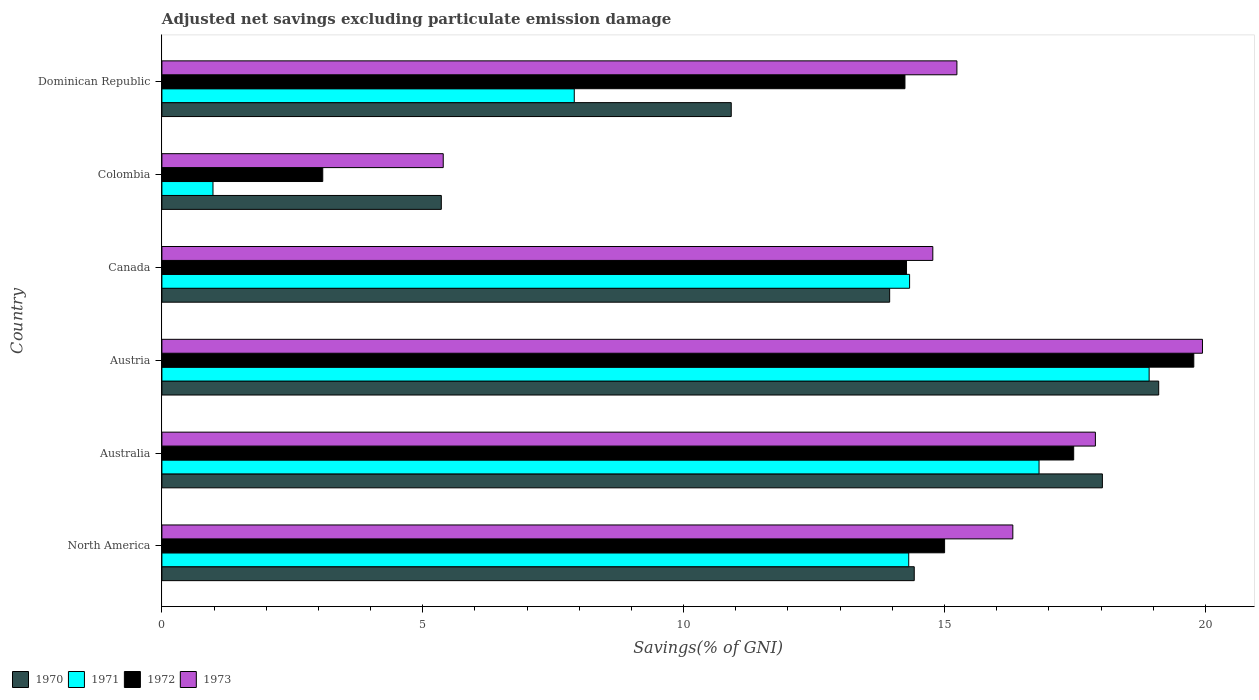Are the number of bars per tick equal to the number of legend labels?
Provide a short and direct response. Yes. How many bars are there on the 4th tick from the bottom?
Your answer should be very brief. 4. What is the adjusted net savings in 1972 in North America?
Provide a short and direct response. 15. Across all countries, what is the maximum adjusted net savings in 1973?
Provide a succinct answer. 19.94. Across all countries, what is the minimum adjusted net savings in 1972?
Make the answer very short. 3.08. In which country was the adjusted net savings in 1972 maximum?
Your answer should be very brief. Austria. In which country was the adjusted net savings in 1970 minimum?
Your response must be concise. Colombia. What is the total adjusted net savings in 1970 in the graph?
Your response must be concise. 81.77. What is the difference between the adjusted net savings in 1972 in Austria and that in Canada?
Provide a succinct answer. 5.51. What is the difference between the adjusted net savings in 1971 in Colombia and the adjusted net savings in 1970 in Canada?
Make the answer very short. -12.97. What is the average adjusted net savings in 1971 per country?
Keep it short and to the point. 12.21. What is the difference between the adjusted net savings in 1970 and adjusted net savings in 1971 in Dominican Republic?
Provide a succinct answer. 3.01. In how many countries, is the adjusted net savings in 1971 greater than 14 %?
Your response must be concise. 4. What is the ratio of the adjusted net savings in 1970 in Australia to that in Austria?
Provide a short and direct response. 0.94. Is the adjusted net savings in 1971 in Australia less than that in North America?
Ensure brevity in your answer.  No. What is the difference between the highest and the second highest adjusted net savings in 1973?
Make the answer very short. 2.05. What is the difference between the highest and the lowest adjusted net savings in 1971?
Your response must be concise. 17.94. What does the 3rd bar from the bottom in Canada represents?
Make the answer very short. 1972. How many countries are there in the graph?
Ensure brevity in your answer.  6. Does the graph contain grids?
Your answer should be very brief. No. What is the title of the graph?
Your answer should be compact. Adjusted net savings excluding particulate emission damage. What is the label or title of the X-axis?
Ensure brevity in your answer.  Savings(% of GNI). What is the label or title of the Y-axis?
Your answer should be very brief. Country. What is the Savings(% of GNI) in 1970 in North America?
Make the answer very short. 14.42. What is the Savings(% of GNI) in 1971 in North America?
Provide a succinct answer. 14.31. What is the Savings(% of GNI) in 1972 in North America?
Offer a very short reply. 15. What is the Savings(% of GNI) in 1973 in North America?
Provide a succinct answer. 16.31. What is the Savings(% of GNI) of 1970 in Australia?
Keep it short and to the point. 18.03. What is the Savings(% of GNI) in 1971 in Australia?
Your response must be concise. 16.81. What is the Savings(% of GNI) in 1972 in Australia?
Your response must be concise. 17.48. What is the Savings(% of GNI) of 1973 in Australia?
Your answer should be compact. 17.89. What is the Savings(% of GNI) of 1970 in Austria?
Offer a very short reply. 19.11. What is the Savings(% of GNI) in 1971 in Austria?
Offer a very short reply. 18.92. What is the Savings(% of GNI) in 1972 in Austria?
Your answer should be compact. 19.78. What is the Savings(% of GNI) of 1973 in Austria?
Provide a succinct answer. 19.94. What is the Savings(% of GNI) in 1970 in Canada?
Provide a succinct answer. 13.95. What is the Savings(% of GNI) in 1971 in Canada?
Offer a terse response. 14.33. What is the Savings(% of GNI) in 1972 in Canada?
Your response must be concise. 14.27. What is the Savings(% of GNI) in 1973 in Canada?
Your answer should be very brief. 14.78. What is the Savings(% of GNI) of 1970 in Colombia?
Ensure brevity in your answer.  5.36. What is the Savings(% of GNI) of 1971 in Colombia?
Provide a short and direct response. 0.98. What is the Savings(% of GNI) in 1972 in Colombia?
Make the answer very short. 3.08. What is the Savings(% of GNI) of 1973 in Colombia?
Your answer should be very brief. 5.39. What is the Savings(% of GNI) of 1970 in Dominican Republic?
Your answer should be very brief. 10.91. What is the Savings(% of GNI) of 1971 in Dominican Republic?
Ensure brevity in your answer.  7.9. What is the Savings(% of GNI) in 1972 in Dominican Republic?
Offer a very short reply. 14.24. What is the Savings(% of GNI) of 1973 in Dominican Republic?
Your answer should be compact. 15.24. Across all countries, what is the maximum Savings(% of GNI) of 1970?
Your answer should be compact. 19.11. Across all countries, what is the maximum Savings(% of GNI) of 1971?
Your answer should be compact. 18.92. Across all countries, what is the maximum Savings(% of GNI) in 1972?
Offer a terse response. 19.78. Across all countries, what is the maximum Savings(% of GNI) of 1973?
Give a very brief answer. 19.94. Across all countries, what is the minimum Savings(% of GNI) in 1970?
Give a very brief answer. 5.36. Across all countries, what is the minimum Savings(% of GNI) of 1971?
Provide a succinct answer. 0.98. Across all countries, what is the minimum Savings(% of GNI) of 1972?
Make the answer very short. 3.08. Across all countries, what is the minimum Savings(% of GNI) of 1973?
Give a very brief answer. 5.39. What is the total Savings(% of GNI) in 1970 in the graph?
Ensure brevity in your answer.  81.77. What is the total Savings(% of GNI) of 1971 in the graph?
Your answer should be compact. 73.26. What is the total Savings(% of GNI) in 1972 in the graph?
Provide a short and direct response. 83.85. What is the total Savings(% of GNI) in 1973 in the graph?
Provide a succinct answer. 89.55. What is the difference between the Savings(% of GNI) of 1970 in North America and that in Australia?
Keep it short and to the point. -3.61. What is the difference between the Savings(% of GNI) of 1971 in North America and that in Australia?
Offer a very short reply. -2.5. What is the difference between the Savings(% of GNI) in 1972 in North America and that in Australia?
Your answer should be compact. -2.47. What is the difference between the Savings(% of GNI) of 1973 in North America and that in Australia?
Give a very brief answer. -1.58. What is the difference between the Savings(% of GNI) of 1970 in North America and that in Austria?
Ensure brevity in your answer.  -4.69. What is the difference between the Savings(% of GNI) in 1971 in North America and that in Austria?
Offer a very short reply. -4.61. What is the difference between the Savings(% of GNI) of 1972 in North America and that in Austria?
Provide a short and direct response. -4.78. What is the difference between the Savings(% of GNI) in 1973 in North America and that in Austria?
Make the answer very short. -3.63. What is the difference between the Savings(% of GNI) in 1970 in North America and that in Canada?
Your answer should be compact. 0.47. What is the difference between the Savings(% of GNI) in 1971 in North America and that in Canada?
Your answer should be very brief. -0.02. What is the difference between the Savings(% of GNI) of 1972 in North America and that in Canada?
Ensure brevity in your answer.  0.73. What is the difference between the Savings(% of GNI) in 1973 in North America and that in Canada?
Your answer should be compact. 1.53. What is the difference between the Savings(% of GNI) of 1970 in North America and that in Colombia?
Provide a short and direct response. 9.06. What is the difference between the Savings(% of GNI) in 1971 in North America and that in Colombia?
Keep it short and to the point. 13.34. What is the difference between the Savings(% of GNI) in 1972 in North America and that in Colombia?
Your response must be concise. 11.92. What is the difference between the Savings(% of GNI) of 1973 in North America and that in Colombia?
Provide a short and direct response. 10.92. What is the difference between the Savings(% of GNI) in 1970 in North America and that in Dominican Republic?
Ensure brevity in your answer.  3.51. What is the difference between the Savings(% of GNI) of 1971 in North America and that in Dominican Republic?
Provide a succinct answer. 6.41. What is the difference between the Savings(% of GNI) in 1972 in North America and that in Dominican Republic?
Give a very brief answer. 0.76. What is the difference between the Savings(% of GNI) of 1973 in North America and that in Dominican Republic?
Your answer should be very brief. 1.07. What is the difference between the Savings(% of GNI) in 1970 in Australia and that in Austria?
Provide a short and direct response. -1.08. What is the difference between the Savings(% of GNI) of 1971 in Australia and that in Austria?
Your answer should be very brief. -2.11. What is the difference between the Savings(% of GNI) in 1972 in Australia and that in Austria?
Make the answer very short. -2.3. What is the difference between the Savings(% of GNI) of 1973 in Australia and that in Austria?
Offer a very short reply. -2.05. What is the difference between the Savings(% of GNI) in 1970 in Australia and that in Canada?
Ensure brevity in your answer.  4.08. What is the difference between the Savings(% of GNI) of 1971 in Australia and that in Canada?
Keep it short and to the point. 2.48. What is the difference between the Savings(% of GNI) in 1972 in Australia and that in Canada?
Provide a succinct answer. 3.2. What is the difference between the Savings(% of GNI) in 1973 in Australia and that in Canada?
Keep it short and to the point. 3.12. What is the difference between the Savings(% of GNI) in 1970 in Australia and that in Colombia?
Make the answer very short. 12.67. What is the difference between the Savings(% of GNI) of 1971 in Australia and that in Colombia?
Offer a terse response. 15.83. What is the difference between the Savings(% of GNI) in 1972 in Australia and that in Colombia?
Provide a short and direct response. 14.39. What is the difference between the Savings(% of GNI) of 1973 in Australia and that in Colombia?
Ensure brevity in your answer.  12.5. What is the difference between the Savings(% of GNI) of 1970 in Australia and that in Dominican Republic?
Provide a short and direct response. 7.11. What is the difference between the Savings(% of GNI) of 1971 in Australia and that in Dominican Republic?
Make the answer very short. 8.91. What is the difference between the Savings(% of GNI) in 1972 in Australia and that in Dominican Republic?
Keep it short and to the point. 3.23. What is the difference between the Savings(% of GNI) of 1973 in Australia and that in Dominican Republic?
Make the answer very short. 2.65. What is the difference between the Savings(% of GNI) of 1970 in Austria and that in Canada?
Keep it short and to the point. 5.16. What is the difference between the Savings(% of GNI) in 1971 in Austria and that in Canada?
Your answer should be compact. 4.59. What is the difference between the Savings(% of GNI) in 1972 in Austria and that in Canada?
Your response must be concise. 5.51. What is the difference between the Savings(% of GNI) in 1973 in Austria and that in Canada?
Provide a succinct answer. 5.17. What is the difference between the Savings(% of GNI) in 1970 in Austria and that in Colombia?
Provide a short and direct response. 13.75. What is the difference between the Savings(% of GNI) of 1971 in Austria and that in Colombia?
Keep it short and to the point. 17.94. What is the difference between the Savings(% of GNI) in 1972 in Austria and that in Colombia?
Provide a succinct answer. 16.7. What is the difference between the Savings(% of GNI) in 1973 in Austria and that in Colombia?
Your answer should be very brief. 14.55. What is the difference between the Savings(% of GNI) of 1970 in Austria and that in Dominican Republic?
Your response must be concise. 8.19. What is the difference between the Savings(% of GNI) of 1971 in Austria and that in Dominican Republic?
Keep it short and to the point. 11.02. What is the difference between the Savings(% of GNI) in 1972 in Austria and that in Dominican Republic?
Ensure brevity in your answer.  5.54. What is the difference between the Savings(% of GNI) of 1973 in Austria and that in Dominican Republic?
Provide a succinct answer. 4.71. What is the difference between the Savings(% of GNI) of 1970 in Canada and that in Colombia?
Ensure brevity in your answer.  8.59. What is the difference between the Savings(% of GNI) of 1971 in Canada and that in Colombia?
Your response must be concise. 13.35. What is the difference between the Savings(% of GNI) in 1972 in Canada and that in Colombia?
Your answer should be compact. 11.19. What is the difference between the Savings(% of GNI) in 1973 in Canada and that in Colombia?
Offer a very short reply. 9.38. What is the difference between the Savings(% of GNI) of 1970 in Canada and that in Dominican Republic?
Give a very brief answer. 3.04. What is the difference between the Savings(% of GNI) in 1971 in Canada and that in Dominican Republic?
Ensure brevity in your answer.  6.43. What is the difference between the Savings(% of GNI) of 1972 in Canada and that in Dominican Republic?
Your answer should be very brief. 0.03. What is the difference between the Savings(% of GNI) in 1973 in Canada and that in Dominican Republic?
Give a very brief answer. -0.46. What is the difference between the Savings(% of GNI) in 1970 in Colombia and that in Dominican Republic?
Your answer should be compact. -5.56. What is the difference between the Savings(% of GNI) of 1971 in Colombia and that in Dominican Republic?
Provide a short and direct response. -6.92. What is the difference between the Savings(% of GNI) in 1972 in Colombia and that in Dominican Republic?
Keep it short and to the point. -11.16. What is the difference between the Savings(% of GNI) in 1973 in Colombia and that in Dominican Republic?
Offer a very short reply. -9.85. What is the difference between the Savings(% of GNI) of 1970 in North America and the Savings(% of GNI) of 1971 in Australia?
Offer a terse response. -2.39. What is the difference between the Savings(% of GNI) in 1970 in North America and the Savings(% of GNI) in 1972 in Australia?
Your response must be concise. -3.06. What is the difference between the Savings(% of GNI) in 1970 in North America and the Savings(% of GNI) in 1973 in Australia?
Keep it short and to the point. -3.47. What is the difference between the Savings(% of GNI) of 1971 in North America and the Savings(% of GNI) of 1972 in Australia?
Provide a short and direct response. -3.16. What is the difference between the Savings(% of GNI) of 1971 in North America and the Savings(% of GNI) of 1973 in Australia?
Provide a short and direct response. -3.58. What is the difference between the Savings(% of GNI) in 1972 in North America and the Savings(% of GNI) in 1973 in Australia?
Provide a succinct answer. -2.89. What is the difference between the Savings(% of GNI) of 1970 in North America and the Savings(% of GNI) of 1971 in Austria?
Your response must be concise. -4.5. What is the difference between the Savings(% of GNI) of 1970 in North America and the Savings(% of GNI) of 1972 in Austria?
Your response must be concise. -5.36. What is the difference between the Savings(% of GNI) in 1970 in North America and the Savings(% of GNI) in 1973 in Austria?
Ensure brevity in your answer.  -5.52. What is the difference between the Savings(% of GNI) in 1971 in North America and the Savings(% of GNI) in 1972 in Austria?
Your answer should be compact. -5.46. What is the difference between the Savings(% of GNI) of 1971 in North America and the Savings(% of GNI) of 1973 in Austria?
Offer a terse response. -5.63. What is the difference between the Savings(% of GNI) in 1972 in North America and the Savings(% of GNI) in 1973 in Austria?
Your answer should be compact. -4.94. What is the difference between the Savings(% of GNI) in 1970 in North America and the Savings(% of GNI) in 1971 in Canada?
Ensure brevity in your answer.  0.09. What is the difference between the Savings(% of GNI) of 1970 in North America and the Savings(% of GNI) of 1972 in Canada?
Ensure brevity in your answer.  0.15. What is the difference between the Savings(% of GNI) in 1970 in North America and the Savings(% of GNI) in 1973 in Canada?
Offer a terse response. -0.36. What is the difference between the Savings(% of GNI) of 1971 in North America and the Savings(% of GNI) of 1972 in Canada?
Keep it short and to the point. 0.04. What is the difference between the Savings(% of GNI) in 1971 in North America and the Savings(% of GNI) in 1973 in Canada?
Provide a short and direct response. -0.46. What is the difference between the Savings(% of GNI) in 1972 in North America and the Savings(% of GNI) in 1973 in Canada?
Ensure brevity in your answer.  0.23. What is the difference between the Savings(% of GNI) in 1970 in North America and the Savings(% of GNI) in 1971 in Colombia?
Your answer should be very brief. 13.44. What is the difference between the Savings(% of GNI) in 1970 in North America and the Savings(% of GNI) in 1972 in Colombia?
Your answer should be compact. 11.34. What is the difference between the Savings(% of GNI) of 1970 in North America and the Savings(% of GNI) of 1973 in Colombia?
Provide a short and direct response. 9.03. What is the difference between the Savings(% of GNI) in 1971 in North America and the Savings(% of GNI) in 1972 in Colombia?
Offer a terse response. 11.23. What is the difference between the Savings(% of GNI) in 1971 in North America and the Savings(% of GNI) in 1973 in Colombia?
Ensure brevity in your answer.  8.92. What is the difference between the Savings(% of GNI) in 1972 in North America and the Savings(% of GNI) in 1973 in Colombia?
Provide a succinct answer. 9.61. What is the difference between the Savings(% of GNI) in 1970 in North America and the Savings(% of GNI) in 1971 in Dominican Republic?
Offer a terse response. 6.52. What is the difference between the Savings(% of GNI) in 1970 in North America and the Savings(% of GNI) in 1972 in Dominican Republic?
Provide a short and direct response. 0.18. What is the difference between the Savings(% of GNI) in 1970 in North America and the Savings(% of GNI) in 1973 in Dominican Republic?
Provide a short and direct response. -0.82. What is the difference between the Savings(% of GNI) of 1971 in North America and the Savings(% of GNI) of 1972 in Dominican Republic?
Your answer should be compact. 0.07. What is the difference between the Savings(% of GNI) of 1971 in North America and the Savings(% of GNI) of 1973 in Dominican Republic?
Your answer should be compact. -0.92. What is the difference between the Savings(% of GNI) of 1972 in North America and the Savings(% of GNI) of 1973 in Dominican Republic?
Offer a very short reply. -0.24. What is the difference between the Savings(% of GNI) of 1970 in Australia and the Savings(% of GNI) of 1971 in Austria?
Make the answer very short. -0.9. What is the difference between the Savings(% of GNI) of 1970 in Australia and the Savings(% of GNI) of 1972 in Austria?
Your answer should be very brief. -1.75. What is the difference between the Savings(% of GNI) in 1970 in Australia and the Savings(% of GNI) in 1973 in Austria?
Ensure brevity in your answer.  -1.92. What is the difference between the Savings(% of GNI) of 1971 in Australia and the Savings(% of GNI) of 1972 in Austria?
Ensure brevity in your answer.  -2.97. What is the difference between the Savings(% of GNI) in 1971 in Australia and the Savings(% of GNI) in 1973 in Austria?
Offer a terse response. -3.13. What is the difference between the Savings(% of GNI) of 1972 in Australia and the Savings(% of GNI) of 1973 in Austria?
Keep it short and to the point. -2.47. What is the difference between the Savings(% of GNI) in 1970 in Australia and the Savings(% of GNI) in 1971 in Canada?
Keep it short and to the point. 3.7. What is the difference between the Savings(% of GNI) of 1970 in Australia and the Savings(% of GNI) of 1972 in Canada?
Offer a very short reply. 3.75. What is the difference between the Savings(% of GNI) in 1970 in Australia and the Savings(% of GNI) in 1973 in Canada?
Your response must be concise. 3.25. What is the difference between the Savings(% of GNI) in 1971 in Australia and the Savings(% of GNI) in 1972 in Canada?
Your answer should be compact. 2.54. What is the difference between the Savings(% of GNI) of 1971 in Australia and the Savings(% of GNI) of 1973 in Canada?
Provide a short and direct response. 2.04. What is the difference between the Savings(% of GNI) in 1972 in Australia and the Savings(% of GNI) in 1973 in Canada?
Offer a terse response. 2.7. What is the difference between the Savings(% of GNI) in 1970 in Australia and the Savings(% of GNI) in 1971 in Colombia?
Your answer should be very brief. 17.05. What is the difference between the Savings(% of GNI) in 1970 in Australia and the Savings(% of GNI) in 1972 in Colombia?
Your response must be concise. 14.94. What is the difference between the Savings(% of GNI) of 1970 in Australia and the Savings(% of GNI) of 1973 in Colombia?
Give a very brief answer. 12.63. What is the difference between the Savings(% of GNI) of 1971 in Australia and the Savings(% of GNI) of 1972 in Colombia?
Your answer should be very brief. 13.73. What is the difference between the Savings(% of GNI) of 1971 in Australia and the Savings(% of GNI) of 1973 in Colombia?
Make the answer very short. 11.42. What is the difference between the Savings(% of GNI) in 1972 in Australia and the Savings(% of GNI) in 1973 in Colombia?
Provide a short and direct response. 12.08. What is the difference between the Savings(% of GNI) of 1970 in Australia and the Savings(% of GNI) of 1971 in Dominican Republic?
Ensure brevity in your answer.  10.12. What is the difference between the Savings(% of GNI) in 1970 in Australia and the Savings(% of GNI) in 1972 in Dominican Republic?
Provide a short and direct response. 3.78. What is the difference between the Savings(% of GNI) in 1970 in Australia and the Savings(% of GNI) in 1973 in Dominican Republic?
Give a very brief answer. 2.79. What is the difference between the Savings(% of GNI) in 1971 in Australia and the Savings(% of GNI) in 1972 in Dominican Republic?
Keep it short and to the point. 2.57. What is the difference between the Savings(% of GNI) of 1971 in Australia and the Savings(% of GNI) of 1973 in Dominican Republic?
Keep it short and to the point. 1.57. What is the difference between the Savings(% of GNI) in 1972 in Australia and the Savings(% of GNI) in 1973 in Dominican Republic?
Ensure brevity in your answer.  2.24. What is the difference between the Savings(% of GNI) in 1970 in Austria and the Savings(% of GNI) in 1971 in Canada?
Make the answer very short. 4.77. What is the difference between the Savings(% of GNI) in 1970 in Austria and the Savings(% of GNI) in 1972 in Canada?
Your response must be concise. 4.83. What is the difference between the Savings(% of GNI) in 1970 in Austria and the Savings(% of GNI) in 1973 in Canada?
Ensure brevity in your answer.  4.33. What is the difference between the Savings(% of GNI) of 1971 in Austria and the Savings(% of GNI) of 1972 in Canada?
Offer a terse response. 4.65. What is the difference between the Savings(% of GNI) of 1971 in Austria and the Savings(% of GNI) of 1973 in Canada?
Give a very brief answer. 4.15. What is the difference between the Savings(% of GNI) of 1972 in Austria and the Savings(% of GNI) of 1973 in Canada?
Ensure brevity in your answer.  5. What is the difference between the Savings(% of GNI) of 1970 in Austria and the Savings(% of GNI) of 1971 in Colombia?
Your answer should be compact. 18.13. What is the difference between the Savings(% of GNI) in 1970 in Austria and the Savings(% of GNI) in 1972 in Colombia?
Your answer should be very brief. 16.02. What is the difference between the Savings(% of GNI) in 1970 in Austria and the Savings(% of GNI) in 1973 in Colombia?
Give a very brief answer. 13.71. What is the difference between the Savings(% of GNI) of 1971 in Austria and the Savings(% of GNI) of 1972 in Colombia?
Your answer should be very brief. 15.84. What is the difference between the Savings(% of GNI) of 1971 in Austria and the Savings(% of GNI) of 1973 in Colombia?
Offer a very short reply. 13.53. What is the difference between the Savings(% of GNI) in 1972 in Austria and the Savings(% of GNI) in 1973 in Colombia?
Offer a very short reply. 14.39. What is the difference between the Savings(% of GNI) of 1970 in Austria and the Savings(% of GNI) of 1971 in Dominican Republic?
Provide a short and direct response. 11.2. What is the difference between the Savings(% of GNI) in 1970 in Austria and the Savings(% of GNI) in 1972 in Dominican Republic?
Give a very brief answer. 4.86. What is the difference between the Savings(% of GNI) of 1970 in Austria and the Savings(% of GNI) of 1973 in Dominican Republic?
Give a very brief answer. 3.87. What is the difference between the Savings(% of GNI) of 1971 in Austria and the Savings(% of GNI) of 1972 in Dominican Republic?
Your answer should be compact. 4.68. What is the difference between the Savings(% of GNI) of 1971 in Austria and the Savings(% of GNI) of 1973 in Dominican Republic?
Provide a succinct answer. 3.68. What is the difference between the Savings(% of GNI) of 1972 in Austria and the Savings(% of GNI) of 1973 in Dominican Republic?
Your answer should be compact. 4.54. What is the difference between the Savings(% of GNI) of 1970 in Canada and the Savings(% of GNI) of 1971 in Colombia?
Your answer should be very brief. 12.97. What is the difference between the Savings(% of GNI) of 1970 in Canada and the Savings(% of GNI) of 1972 in Colombia?
Offer a very short reply. 10.87. What is the difference between the Savings(% of GNI) of 1970 in Canada and the Savings(% of GNI) of 1973 in Colombia?
Ensure brevity in your answer.  8.56. What is the difference between the Savings(% of GNI) in 1971 in Canada and the Savings(% of GNI) in 1972 in Colombia?
Give a very brief answer. 11.25. What is the difference between the Savings(% of GNI) of 1971 in Canada and the Savings(% of GNI) of 1973 in Colombia?
Your answer should be compact. 8.94. What is the difference between the Savings(% of GNI) of 1972 in Canada and the Savings(% of GNI) of 1973 in Colombia?
Your answer should be compact. 8.88. What is the difference between the Savings(% of GNI) of 1970 in Canada and the Savings(% of GNI) of 1971 in Dominican Republic?
Your response must be concise. 6.05. What is the difference between the Savings(% of GNI) in 1970 in Canada and the Savings(% of GNI) in 1972 in Dominican Republic?
Keep it short and to the point. -0.29. What is the difference between the Savings(% of GNI) of 1970 in Canada and the Savings(% of GNI) of 1973 in Dominican Republic?
Offer a very short reply. -1.29. What is the difference between the Savings(% of GNI) in 1971 in Canada and the Savings(% of GNI) in 1972 in Dominican Republic?
Provide a short and direct response. 0.09. What is the difference between the Savings(% of GNI) in 1971 in Canada and the Savings(% of GNI) in 1973 in Dominican Republic?
Your answer should be very brief. -0.91. What is the difference between the Savings(% of GNI) in 1972 in Canada and the Savings(% of GNI) in 1973 in Dominican Republic?
Your answer should be compact. -0.97. What is the difference between the Savings(% of GNI) of 1970 in Colombia and the Savings(% of GNI) of 1971 in Dominican Republic?
Your response must be concise. -2.55. What is the difference between the Savings(% of GNI) of 1970 in Colombia and the Savings(% of GNI) of 1972 in Dominican Republic?
Your answer should be very brief. -8.89. What is the difference between the Savings(% of GNI) in 1970 in Colombia and the Savings(% of GNI) in 1973 in Dominican Republic?
Provide a succinct answer. -9.88. What is the difference between the Savings(% of GNI) of 1971 in Colombia and the Savings(% of GNI) of 1972 in Dominican Republic?
Provide a succinct answer. -13.26. What is the difference between the Savings(% of GNI) in 1971 in Colombia and the Savings(% of GNI) in 1973 in Dominican Republic?
Ensure brevity in your answer.  -14.26. What is the difference between the Savings(% of GNI) in 1972 in Colombia and the Savings(% of GNI) in 1973 in Dominican Republic?
Provide a succinct answer. -12.15. What is the average Savings(% of GNI) in 1970 per country?
Your response must be concise. 13.63. What is the average Savings(% of GNI) of 1971 per country?
Your response must be concise. 12.21. What is the average Savings(% of GNI) of 1972 per country?
Provide a succinct answer. 13.98. What is the average Savings(% of GNI) in 1973 per country?
Ensure brevity in your answer.  14.93. What is the difference between the Savings(% of GNI) in 1970 and Savings(% of GNI) in 1971 in North America?
Provide a succinct answer. 0.11. What is the difference between the Savings(% of GNI) of 1970 and Savings(% of GNI) of 1972 in North America?
Offer a terse response. -0.58. What is the difference between the Savings(% of GNI) of 1970 and Savings(% of GNI) of 1973 in North America?
Offer a very short reply. -1.89. What is the difference between the Savings(% of GNI) in 1971 and Savings(% of GNI) in 1972 in North America?
Offer a very short reply. -0.69. What is the difference between the Savings(% of GNI) of 1971 and Savings(% of GNI) of 1973 in North America?
Ensure brevity in your answer.  -2. What is the difference between the Savings(% of GNI) in 1972 and Savings(% of GNI) in 1973 in North America?
Your response must be concise. -1.31. What is the difference between the Savings(% of GNI) in 1970 and Savings(% of GNI) in 1971 in Australia?
Provide a short and direct response. 1.21. What is the difference between the Savings(% of GNI) in 1970 and Savings(% of GNI) in 1972 in Australia?
Provide a succinct answer. 0.55. What is the difference between the Savings(% of GNI) of 1970 and Savings(% of GNI) of 1973 in Australia?
Your response must be concise. 0.13. What is the difference between the Savings(% of GNI) of 1971 and Savings(% of GNI) of 1972 in Australia?
Offer a terse response. -0.66. What is the difference between the Savings(% of GNI) of 1971 and Savings(% of GNI) of 1973 in Australia?
Your answer should be compact. -1.08. What is the difference between the Savings(% of GNI) in 1972 and Savings(% of GNI) in 1973 in Australia?
Offer a very short reply. -0.42. What is the difference between the Savings(% of GNI) of 1970 and Savings(% of GNI) of 1971 in Austria?
Provide a succinct answer. 0.18. What is the difference between the Savings(% of GNI) of 1970 and Savings(% of GNI) of 1972 in Austria?
Provide a short and direct response. -0.67. What is the difference between the Savings(% of GNI) in 1970 and Savings(% of GNI) in 1973 in Austria?
Ensure brevity in your answer.  -0.84. What is the difference between the Savings(% of GNI) in 1971 and Savings(% of GNI) in 1972 in Austria?
Offer a very short reply. -0.86. What is the difference between the Savings(% of GNI) of 1971 and Savings(% of GNI) of 1973 in Austria?
Your response must be concise. -1.02. What is the difference between the Savings(% of GNI) of 1972 and Savings(% of GNI) of 1973 in Austria?
Your answer should be very brief. -0.17. What is the difference between the Savings(% of GNI) in 1970 and Savings(% of GNI) in 1971 in Canada?
Keep it short and to the point. -0.38. What is the difference between the Savings(% of GNI) of 1970 and Savings(% of GNI) of 1972 in Canada?
Provide a short and direct response. -0.32. What is the difference between the Savings(% of GNI) of 1970 and Savings(% of GNI) of 1973 in Canada?
Your answer should be compact. -0.83. What is the difference between the Savings(% of GNI) of 1971 and Savings(% of GNI) of 1972 in Canada?
Offer a terse response. 0.06. What is the difference between the Savings(% of GNI) of 1971 and Savings(% of GNI) of 1973 in Canada?
Ensure brevity in your answer.  -0.45. What is the difference between the Savings(% of GNI) in 1972 and Savings(% of GNI) in 1973 in Canada?
Offer a terse response. -0.5. What is the difference between the Savings(% of GNI) of 1970 and Savings(% of GNI) of 1971 in Colombia?
Offer a very short reply. 4.38. What is the difference between the Savings(% of GNI) of 1970 and Savings(% of GNI) of 1972 in Colombia?
Keep it short and to the point. 2.27. What is the difference between the Savings(% of GNI) of 1970 and Savings(% of GNI) of 1973 in Colombia?
Your answer should be compact. -0.04. What is the difference between the Savings(% of GNI) of 1971 and Savings(% of GNI) of 1972 in Colombia?
Ensure brevity in your answer.  -2.1. What is the difference between the Savings(% of GNI) of 1971 and Savings(% of GNI) of 1973 in Colombia?
Provide a succinct answer. -4.41. What is the difference between the Savings(% of GNI) of 1972 and Savings(% of GNI) of 1973 in Colombia?
Keep it short and to the point. -2.31. What is the difference between the Savings(% of GNI) of 1970 and Savings(% of GNI) of 1971 in Dominican Republic?
Provide a succinct answer. 3.01. What is the difference between the Savings(% of GNI) in 1970 and Savings(% of GNI) in 1972 in Dominican Republic?
Provide a short and direct response. -3.33. What is the difference between the Savings(% of GNI) in 1970 and Savings(% of GNI) in 1973 in Dominican Republic?
Ensure brevity in your answer.  -4.33. What is the difference between the Savings(% of GNI) of 1971 and Savings(% of GNI) of 1972 in Dominican Republic?
Ensure brevity in your answer.  -6.34. What is the difference between the Savings(% of GNI) of 1971 and Savings(% of GNI) of 1973 in Dominican Republic?
Your answer should be compact. -7.33. What is the difference between the Savings(% of GNI) in 1972 and Savings(% of GNI) in 1973 in Dominican Republic?
Your answer should be very brief. -1. What is the ratio of the Savings(% of GNI) of 1970 in North America to that in Australia?
Provide a succinct answer. 0.8. What is the ratio of the Savings(% of GNI) in 1971 in North America to that in Australia?
Offer a very short reply. 0.85. What is the ratio of the Savings(% of GNI) in 1972 in North America to that in Australia?
Your answer should be very brief. 0.86. What is the ratio of the Savings(% of GNI) of 1973 in North America to that in Australia?
Your answer should be compact. 0.91. What is the ratio of the Savings(% of GNI) of 1970 in North America to that in Austria?
Ensure brevity in your answer.  0.75. What is the ratio of the Savings(% of GNI) in 1971 in North America to that in Austria?
Make the answer very short. 0.76. What is the ratio of the Savings(% of GNI) in 1972 in North America to that in Austria?
Ensure brevity in your answer.  0.76. What is the ratio of the Savings(% of GNI) in 1973 in North America to that in Austria?
Offer a terse response. 0.82. What is the ratio of the Savings(% of GNI) in 1970 in North America to that in Canada?
Your answer should be compact. 1.03. What is the ratio of the Savings(% of GNI) in 1971 in North America to that in Canada?
Provide a succinct answer. 1. What is the ratio of the Savings(% of GNI) in 1972 in North America to that in Canada?
Provide a short and direct response. 1.05. What is the ratio of the Savings(% of GNI) of 1973 in North America to that in Canada?
Keep it short and to the point. 1.1. What is the ratio of the Savings(% of GNI) in 1970 in North America to that in Colombia?
Your response must be concise. 2.69. What is the ratio of the Savings(% of GNI) of 1971 in North America to that in Colombia?
Provide a short and direct response. 14.62. What is the ratio of the Savings(% of GNI) in 1972 in North America to that in Colombia?
Ensure brevity in your answer.  4.87. What is the ratio of the Savings(% of GNI) in 1973 in North America to that in Colombia?
Provide a short and direct response. 3.02. What is the ratio of the Savings(% of GNI) in 1970 in North America to that in Dominican Republic?
Ensure brevity in your answer.  1.32. What is the ratio of the Savings(% of GNI) of 1971 in North America to that in Dominican Republic?
Provide a succinct answer. 1.81. What is the ratio of the Savings(% of GNI) of 1972 in North America to that in Dominican Republic?
Your answer should be very brief. 1.05. What is the ratio of the Savings(% of GNI) of 1973 in North America to that in Dominican Republic?
Give a very brief answer. 1.07. What is the ratio of the Savings(% of GNI) in 1970 in Australia to that in Austria?
Your answer should be very brief. 0.94. What is the ratio of the Savings(% of GNI) of 1971 in Australia to that in Austria?
Your answer should be very brief. 0.89. What is the ratio of the Savings(% of GNI) in 1972 in Australia to that in Austria?
Ensure brevity in your answer.  0.88. What is the ratio of the Savings(% of GNI) in 1973 in Australia to that in Austria?
Give a very brief answer. 0.9. What is the ratio of the Savings(% of GNI) in 1970 in Australia to that in Canada?
Provide a succinct answer. 1.29. What is the ratio of the Savings(% of GNI) in 1971 in Australia to that in Canada?
Provide a succinct answer. 1.17. What is the ratio of the Savings(% of GNI) in 1972 in Australia to that in Canada?
Ensure brevity in your answer.  1.22. What is the ratio of the Savings(% of GNI) of 1973 in Australia to that in Canada?
Make the answer very short. 1.21. What is the ratio of the Savings(% of GNI) of 1970 in Australia to that in Colombia?
Make the answer very short. 3.37. What is the ratio of the Savings(% of GNI) in 1971 in Australia to that in Colombia?
Give a very brief answer. 17.17. What is the ratio of the Savings(% of GNI) of 1972 in Australia to that in Colombia?
Keep it short and to the point. 5.67. What is the ratio of the Savings(% of GNI) in 1973 in Australia to that in Colombia?
Ensure brevity in your answer.  3.32. What is the ratio of the Savings(% of GNI) of 1970 in Australia to that in Dominican Republic?
Offer a very short reply. 1.65. What is the ratio of the Savings(% of GNI) of 1971 in Australia to that in Dominican Republic?
Provide a succinct answer. 2.13. What is the ratio of the Savings(% of GNI) in 1972 in Australia to that in Dominican Republic?
Your response must be concise. 1.23. What is the ratio of the Savings(% of GNI) of 1973 in Australia to that in Dominican Republic?
Your response must be concise. 1.17. What is the ratio of the Savings(% of GNI) of 1970 in Austria to that in Canada?
Your answer should be compact. 1.37. What is the ratio of the Savings(% of GNI) of 1971 in Austria to that in Canada?
Give a very brief answer. 1.32. What is the ratio of the Savings(% of GNI) of 1972 in Austria to that in Canada?
Keep it short and to the point. 1.39. What is the ratio of the Savings(% of GNI) in 1973 in Austria to that in Canada?
Keep it short and to the point. 1.35. What is the ratio of the Savings(% of GNI) in 1970 in Austria to that in Colombia?
Your answer should be very brief. 3.57. What is the ratio of the Savings(% of GNI) of 1971 in Austria to that in Colombia?
Your answer should be compact. 19.32. What is the ratio of the Savings(% of GNI) of 1972 in Austria to that in Colombia?
Your answer should be compact. 6.42. What is the ratio of the Savings(% of GNI) of 1973 in Austria to that in Colombia?
Ensure brevity in your answer.  3.7. What is the ratio of the Savings(% of GNI) of 1970 in Austria to that in Dominican Republic?
Ensure brevity in your answer.  1.75. What is the ratio of the Savings(% of GNI) in 1971 in Austria to that in Dominican Republic?
Give a very brief answer. 2.39. What is the ratio of the Savings(% of GNI) in 1972 in Austria to that in Dominican Republic?
Keep it short and to the point. 1.39. What is the ratio of the Savings(% of GNI) in 1973 in Austria to that in Dominican Republic?
Your answer should be compact. 1.31. What is the ratio of the Savings(% of GNI) in 1970 in Canada to that in Colombia?
Provide a short and direct response. 2.6. What is the ratio of the Savings(% of GNI) of 1971 in Canada to that in Colombia?
Your answer should be very brief. 14.64. What is the ratio of the Savings(% of GNI) of 1972 in Canada to that in Colombia?
Give a very brief answer. 4.63. What is the ratio of the Savings(% of GNI) in 1973 in Canada to that in Colombia?
Give a very brief answer. 2.74. What is the ratio of the Savings(% of GNI) in 1970 in Canada to that in Dominican Republic?
Your answer should be very brief. 1.28. What is the ratio of the Savings(% of GNI) in 1971 in Canada to that in Dominican Republic?
Provide a succinct answer. 1.81. What is the ratio of the Savings(% of GNI) of 1972 in Canada to that in Dominican Republic?
Make the answer very short. 1. What is the ratio of the Savings(% of GNI) in 1973 in Canada to that in Dominican Republic?
Your response must be concise. 0.97. What is the ratio of the Savings(% of GNI) of 1970 in Colombia to that in Dominican Republic?
Your response must be concise. 0.49. What is the ratio of the Savings(% of GNI) of 1971 in Colombia to that in Dominican Republic?
Make the answer very short. 0.12. What is the ratio of the Savings(% of GNI) of 1972 in Colombia to that in Dominican Republic?
Offer a terse response. 0.22. What is the ratio of the Savings(% of GNI) of 1973 in Colombia to that in Dominican Republic?
Your response must be concise. 0.35. What is the difference between the highest and the second highest Savings(% of GNI) in 1970?
Your answer should be compact. 1.08. What is the difference between the highest and the second highest Savings(% of GNI) of 1971?
Provide a short and direct response. 2.11. What is the difference between the highest and the second highest Savings(% of GNI) in 1972?
Your answer should be very brief. 2.3. What is the difference between the highest and the second highest Savings(% of GNI) in 1973?
Offer a very short reply. 2.05. What is the difference between the highest and the lowest Savings(% of GNI) in 1970?
Offer a very short reply. 13.75. What is the difference between the highest and the lowest Savings(% of GNI) in 1971?
Keep it short and to the point. 17.94. What is the difference between the highest and the lowest Savings(% of GNI) of 1972?
Make the answer very short. 16.7. What is the difference between the highest and the lowest Savings(% of GNI) of 1973?
Make the answer very short. 14.55. 